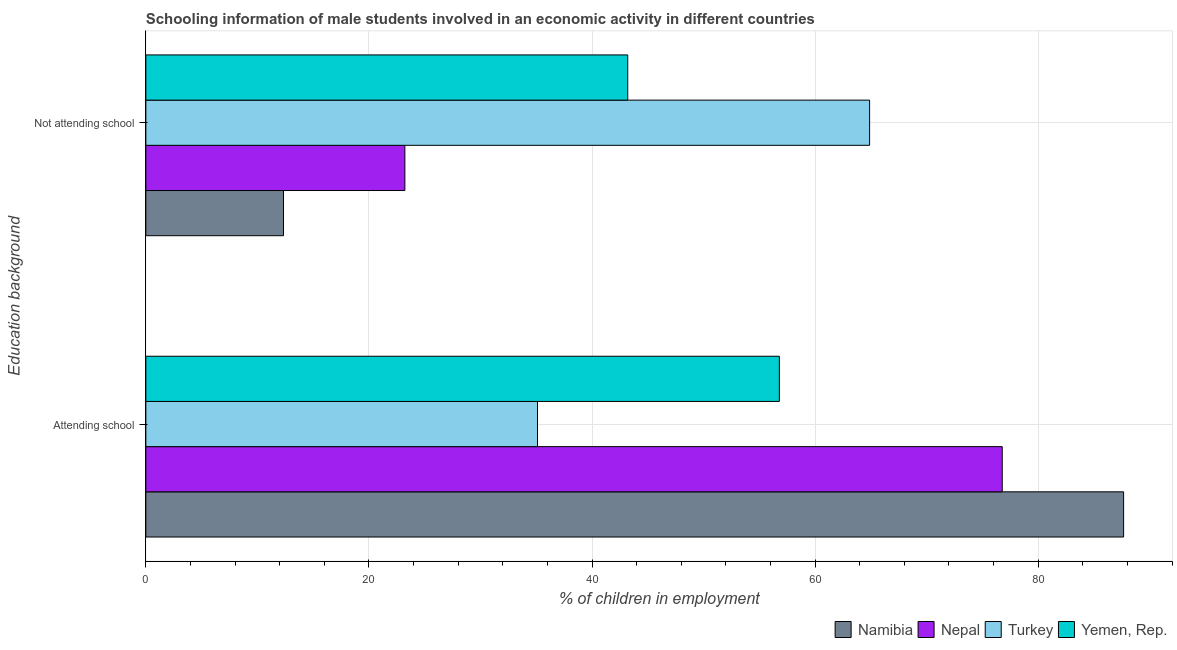Are the number of bars per tick equal to the number of legend labels?
Offer a very short reply. Yes. How many bars are there on the 2nd tick from the bottom?
Your answer should be very brief. 4. What is the label of the 2nd group of bars from the top?
Your answer should be very brief. Attending school. What is the percentage of employed males who are not attending school in Turkey?
Give a very brief answer. 64.89. Across all countries, what is the maximum percentage of employed males who are attending school?
Offer a terse response. 87.66. Across all countries, what is the minimum percentage of employed males who are not attending school?
Make the answer very short. 12.34. In which country was the percentage of employed males who are attending school maximum?
Offer a terse response. Namibia. In which country was the percentage of employed males who are not attending school minimum?
Keep it short and to the point. Namibia. What is the total percentage of employed males who are attending school in the graph?
Offer a terse response. 256.34. What is the difference between the percentage of employed males who are not attending school in Namibia and that in Yemen, Rep.?
Provide a succinct answer. -30.86. What is the difference between the percentage of employed males who are attending school in Turkey and the percentage of employed males who are not attending school in Yemen, Rep.?
Offer a very short reply. -8.09. What is the average percentage of employed males who are attending school per country?
Offer a very short reply. 64.09. What is the difference between the percentage of employed males who are not attending school and percentage of employed males who are attending school in Yemen, Rep.?
Ensure brevity in your answer.  -13.59. What is the ratio of the percentage of employed males who are not attending school in Namibia to that in Nepal?
Provide a short and direct response. 0.53. Is the percentage of employed males who are attending school in Nepal less than that in Namibia?
Provide a succinct answer. Yes. In how many countries, is the percentage of employed males who are attending school greater than the average percentage of employed males who are attending school taken over all countries?
Your answer should be compact. 2. What does the 1st bar from the top in Attending school represents?
Your response must be concise. Yemen, Rep. How many bars are there?
Make the answer very short. 8. What is the difference between two consecutive major ticks on the X-axis?
Your answer should be very brief. 20. Does the graph contain any zero values?
Your response must be concise. No. Does the graph contain grids?
Keep it short and to the point. Yes. How are the legend labels stacked?
Keep it short and to the point. Horizontal. What is the title of the graph?
Make the answer very short. Schooling information of male students involved in an economic activity in different countries. Does "Caribbean small states" appear as one of the legend labels in the graph?
Offer a terse response. No. What is the label or title of the X-axis?
Provide a succinct answer. % of children in employment. What is the label or title of the Y-axis?
Keep it short and to the point. Education background. What is the % of children in employment of Namibia in Attending school?
Ensure brevity in your answer.  87.66. What is the % of children in employment of Nepal in Attending school?
Your response must be concise. 76.78. What is the % of children in employment of Turkey in Attending school?
Your answer should be compact. 35.11. What is the % of children in employment of Yemen, Rep. in Attending school?
Your answer should be compact. 56.8. What is the % of children in employment in Namibia in Not attending school?
Your answer should be compact. 12.34. What is the % of children in employment in Nepal in Not attending school?
Ensure brevity in your answer.  23.22. What is the % of children in employment in Turkey in Not attending school?
Your response must be concise. 64.89. What is the % of children in employment of Yemen, Rep. in Not attending school?
Make the answer very short. 43.2. Across all Education background, what is the maximum % of children in employment in Namibia?
Offer a very short reply. 87.66. Across all Education background, what is the maximum % of children in employment of Nepal?
Your response must be concise. 76.78. Across all Education background, what is the maximum % of children in employment in Turkey?
Make the answer very short. 64.89. Across all Education background, what is the maximum % of children in employment of Yemen, Rep.?
Provide a short and direct response. 56.8. Across all Education background, what is the minimum % of children in employment in Namibia?
Your answer should be very brief. 12.34. Across all Education background, what is the minimum % of children in employment in Nepal?
Provide a succinct answer. 23.22. Across all Education background, what is the minimum % of children in employment in Turkey?
Keep it short and to the point. 35.11. Across all Education background, what is the minimum % of children in employment in Yemen, Rep.?
Provide a short and direct response. 43.2. What is the total % of children in employment in Namibia in the graph?
Your answer should be compact. 100. What is the total % of children in employment of Nepal in the graph?
Your response must be concise. 100. What is the difference between the % of children in employment in Namibia in Attending school and that in Not attending school?
Your answer should be very brief. 75.32. What is the difference between the % of children in employment of Nepal in Attending school and that in Not attending school?
Provide a short and direct response. 53.55. What is the difference between the % of children in employment of Turkey in Attending school and that in Not attending school?
Keep it short and to the point. -29.77. What is the difference between the % of children in employment of Yemen, Rep. in Attending school and that in Not attending school?
Your answer should be compact. 13.59. What is the difference between the % of children in employment of Namibia in Attending school and the % of children in employment of Nepal in Not attending school?
Provide a short and direct response. 64.43. What is the difference between the % of children in employment of Namibia in Attending school and the % of children in employment of Turkey in Not attending school?
Provide a short and direct response. 22.77. What is the difference between the % of children in employment of Namibia in Attending school and the % of children in employment of Yemen, Rep. in Not attending school?
Your response must be concise. 44.45. What is the difference between the % of children in employment of Nepal in Attending school and the % of children in employment of Turkey in Not attending school?
Provide a succinct answer. 11.89. What is the difference between the % of children in employment in Nepal in Attending school and the % of children in employment in Yemen, Rep. in Not attending school?
Ensure brevity in your answer.  33.57. What is the difference between the % of children in employment in Turkey in Attending school and the % of children in employment in Yemen, Rep. in Not attending school?
Provide a succinct answer. -8.09. What is the average % of children in employment in Turkey per Education background?
Make the answer very short. 50. What is the difference between the % of children in employment of Namibia and % of children in employment of Nepal in Attending school?
Offer a terse response. 10.88. What is the difference between the % of children in employment of Namibia and % of children in employment of Turkey in Attending school?
Offer a very short reply. 52.54. What is the difference between the % of children in employment of Namibia and % of children in employment of Yemen, Rep. in Attending school?
Provide a succinct answer. 30.86. What is the difference between the % of children in employment in Nepal and % of children in employment in Turkey in Attending school?
Offer a very short reply. 41.66. What is the difference between the % of children in employment of Nepal and % of children in employment of Yemen, Rep. in Attending school?
Keep it short and to the point. 19.98. What is the difference between the % of children in employment in Turkey and % of children in employment in Yemen, Rep. in Attending school?
Offer a terse response. -21.68. What is the difference between the % of children in employment in Namibia and % of children in employment in Nepal in Not attending school?
Provide a succinct answer. -10.88. What is the difference between the % of children in employment of Namibia and % of children in employment of Turkey in Not attending school?
Keep it short and to the point. -52.54. What is the difference between the % of children in employment in Namibia and % of children in employment in Yemen, Rep. in Not attending school?
Your answer should be compact. -30.86. What is the difference between the % of children in employment in Nepal and % of children in employment in Turkey in Not attending school?
Your response must be concise. -41.66. What is the difference between the % of children in employment in Nepal and % of children in employment in Yemen, Rep. in Not attending school?
Ensure brevity in your answer.  -19.98. What is the difference between the % of children in employment of Turkey and % of children in employment of Yemen, Rep. in Not attending school?
Offer a terse response. 21.68. What is the ratio of the % of children in employment in Namibia in Attending school to that in Not attending school?
Provide a succinct answer. 7.1. What is the ratio of the % of children in employment of Nepal in Attending school to that in Not attending school?
Make the answer very short. 3.31. What is the ratio of the % of children in employment of Turkey in Attending school to that in Not attending school?
Ensure brevity in your answer.  0.54. What is the ratio of the % of children in employment of Yemen, Rep. in Attending school to that in Not attending school?
Offer a very short reply. 1.31. What is the difference between the highest and the second highest % of children in employment in Namibia?
Your answer should be very brief. 75.32. What is the difference between the highest and the second highest % of children in employment of Nepal?
Ensure brevity in your answer.  53.55. What is the difference between the highest and the second highest % of children in employment in Turkey?
Your answer should be compact. 29.77. What is the difference between the highest and the second highest % of children in employment in Yemen, Rep.?
Your response must be concise. 13.59. What is the difference between the highest and the lowest % of children in employment of Namibia?
Offer a very short reply. 75.32. What is the difference between the highest and the lowest % of children in employment in Nepal?
Provide a short and direct response. 53.55. What is the difference between the highest and the lowest % of children in employment of Turkey?
Give a very brief answer. 29.77. What is the difference between the highest and the lowest % of children in employment of Yemen, Rep.?
Your answer should be compact. 13.59. 